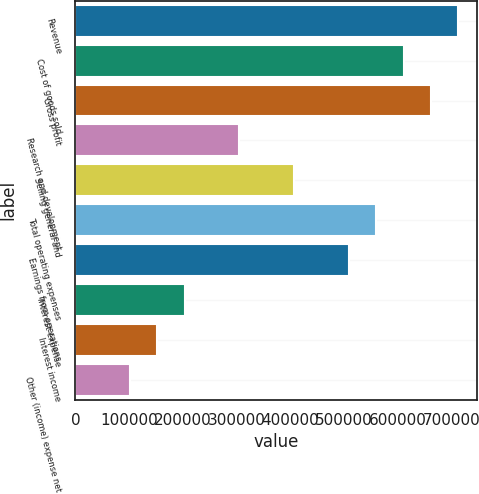Convert chart. <chart><loc_0><loc_0><loc_500><loc_500><bar_chart><fcel>Revenue<fcel>Cost of goods sold<fcel>Gross profit<fcel>Research and development<fcel>Selling general and<fcel>Total operating expenses<fcel>Earnings from operations<fcel>Interest expense<fcel>Interest income<fcel>Other (income) expense net<nl><fcel>711985<fcel>610273<fcel>661129<fcel>305137<fcel>406849<fcel>559417<fcel>508561<fcel>203425<fcel>152569<fcel>101713<nl></chart> 